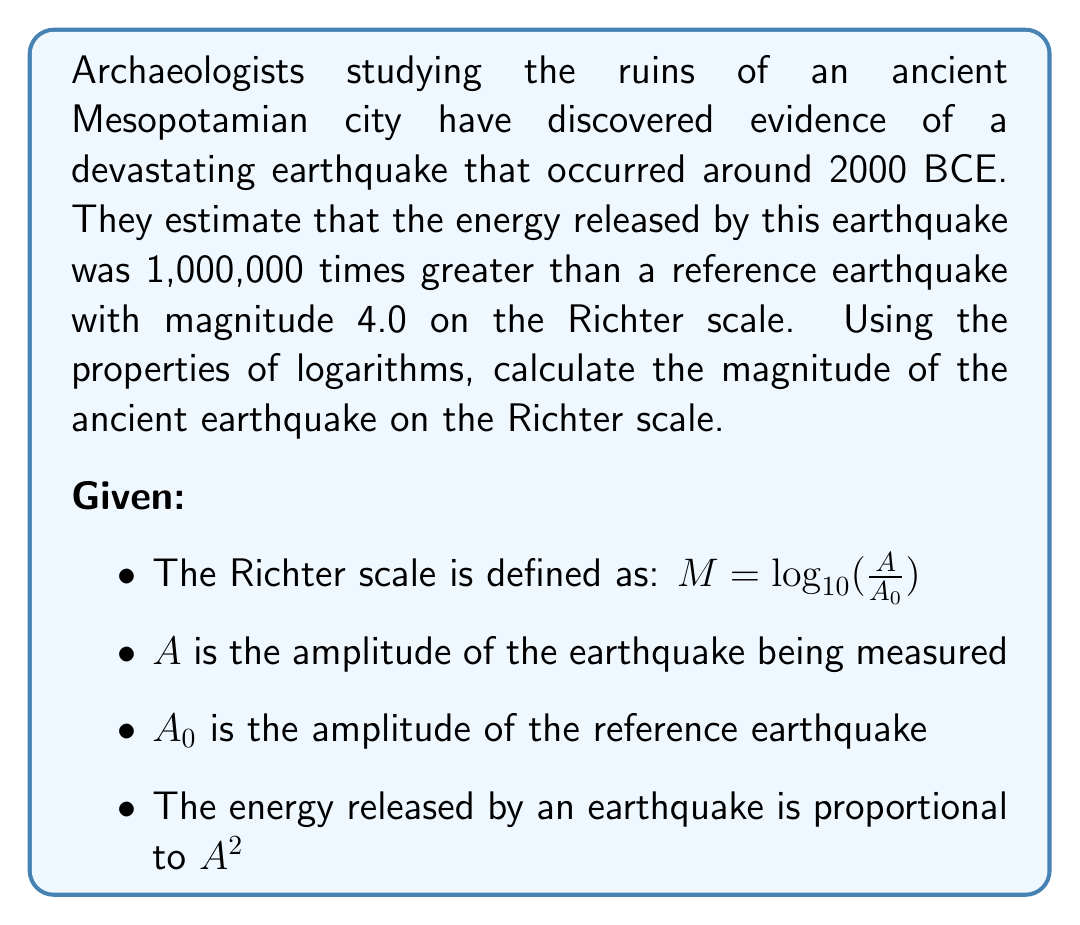Teach me how to tackle this problem. Let's approach this step-by-step:

1) We're told that the energy of the ancient earthquake is 1,000,000 times greater than the reference earthquake. Since energy is proportional to $A^2$, we can write:

   $(\frac{A}{A_0})^2 = 1,000,000$

2) Taking the square root of both sides:

   $\frac{A}{A_0} = \sqrt{1,000,000} = 1,000$

3) Now, let's use the Richter scale formula:

   $M = \log_{10}(\frac{A}{A_0})$

4) We can substitute our value for $\frac{A}{A_0}$:

   $M = \log_{10}(1,000)$

5) Using the properties of logarithms:

   $M = \log_{10}(10^3) = 3$

6) We're told that the reference earthquake has a magnitude of 4.0, so we need to add this to our result:

   $M = 3 + 4.0 = 7.0$

Therefore, the magnitude of the ancient earthquake on the Richter scale is 7.0.
Answer: The magnitude of the ancient earthquake on the Richter scale is 7.0. 